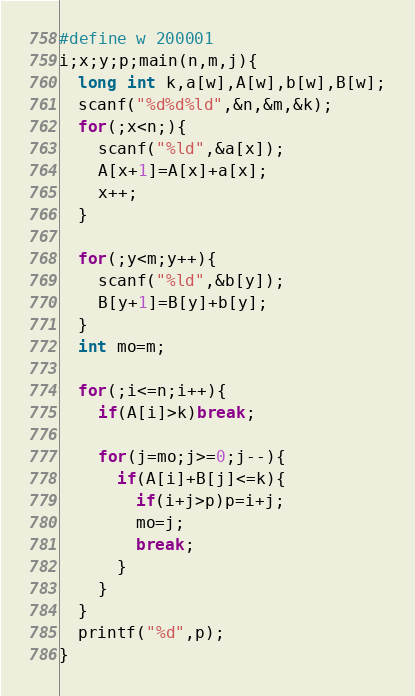<code> <loc_0><loc_0><loc_500><loc_500><_C_>#define w 200001
i;x;y;p;main(n,m,j){
  long int k,a[w],A[w],b[w],B[w];
  scanf("%d%d%ld",&n,&m,&k);
  for(;x<n;){
    scanf("%ld",&a[x]);
    A[x+1]=A[x]+a[x];
    x++;
  }
    
  for(;y<m;y++){
    scanf("%ld",&b[y]);
    B[y+1]=B[y]+b[y];
  }
  int mo=m;
        
  for(;i<=n;i++){
    if(A[i]>k)break;
            
    for(j=mo;j>=0;j--){
      if(A[i]+B[j]<=k){
        if(i+j>p)p=i+j;
        mo=j;
        break;
      }
    }
  }
  printf("%d",p);
}</code> 